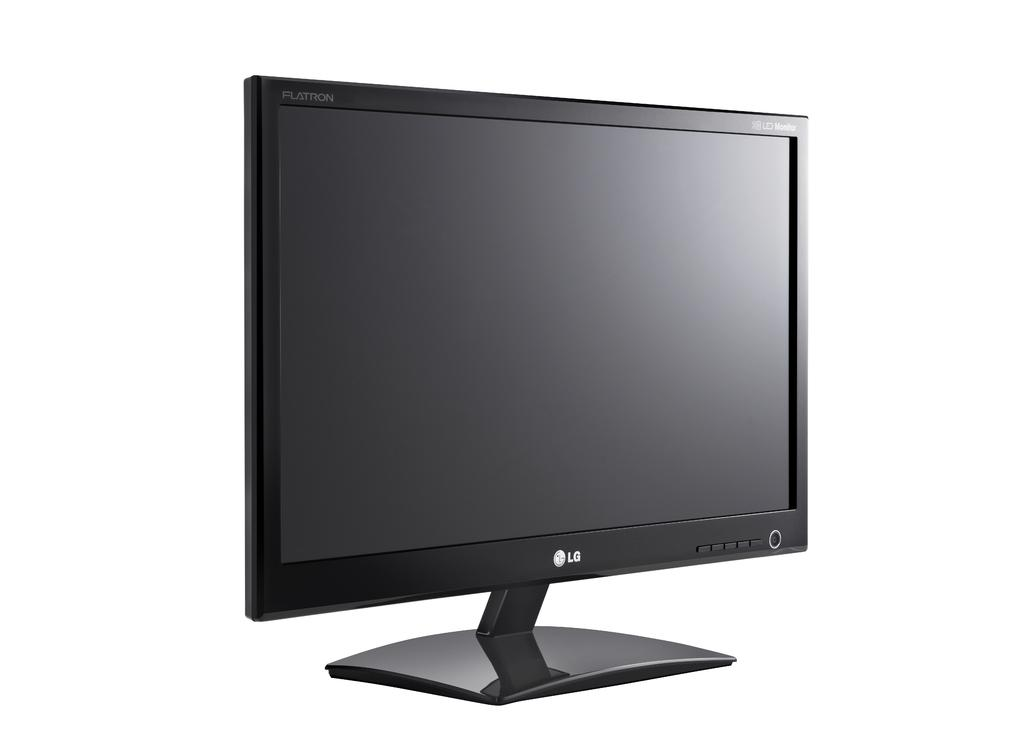<image>
Render a clear and concise summary of the photo. an LG computer monitor with a flatron screen 